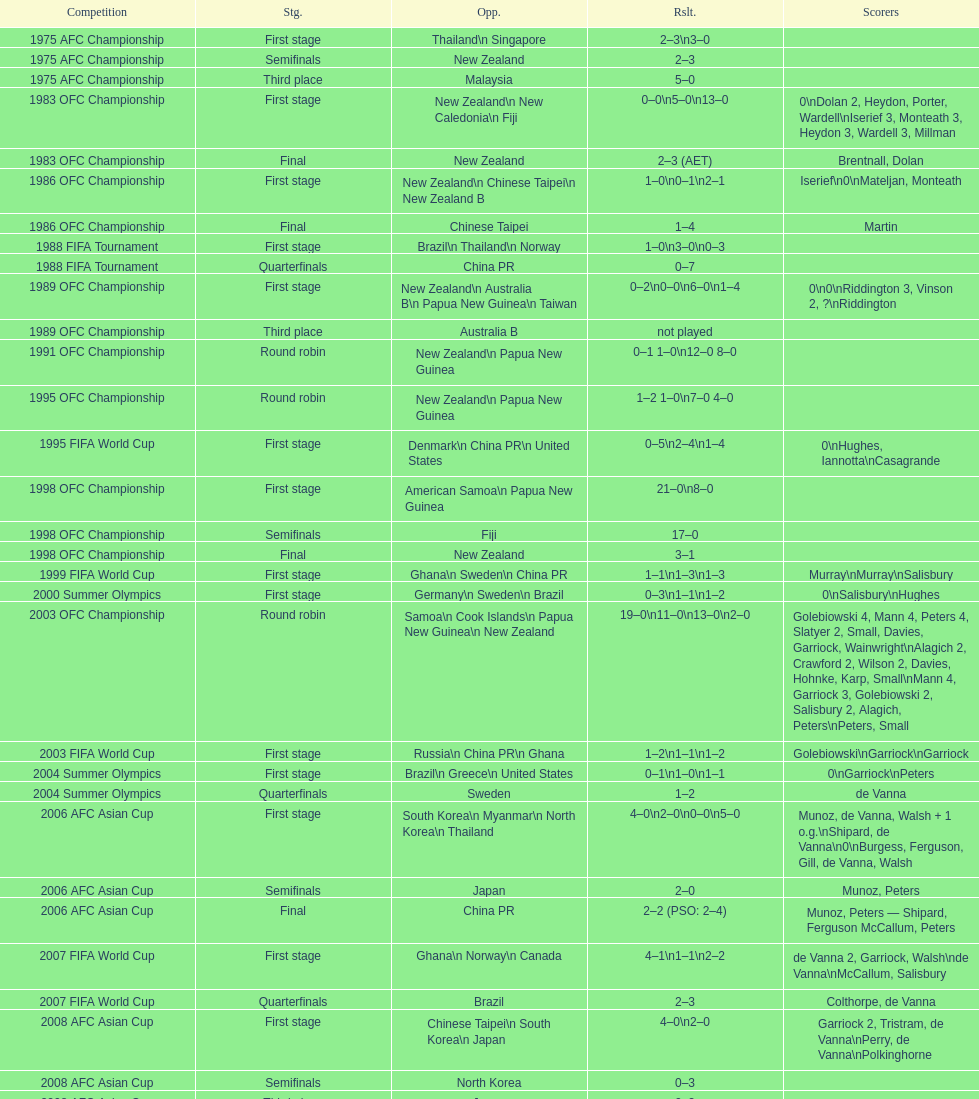What is the discrepancy in the total goals scored between the 1999 fifa world cup and the 2000 summer olympics? 2. 